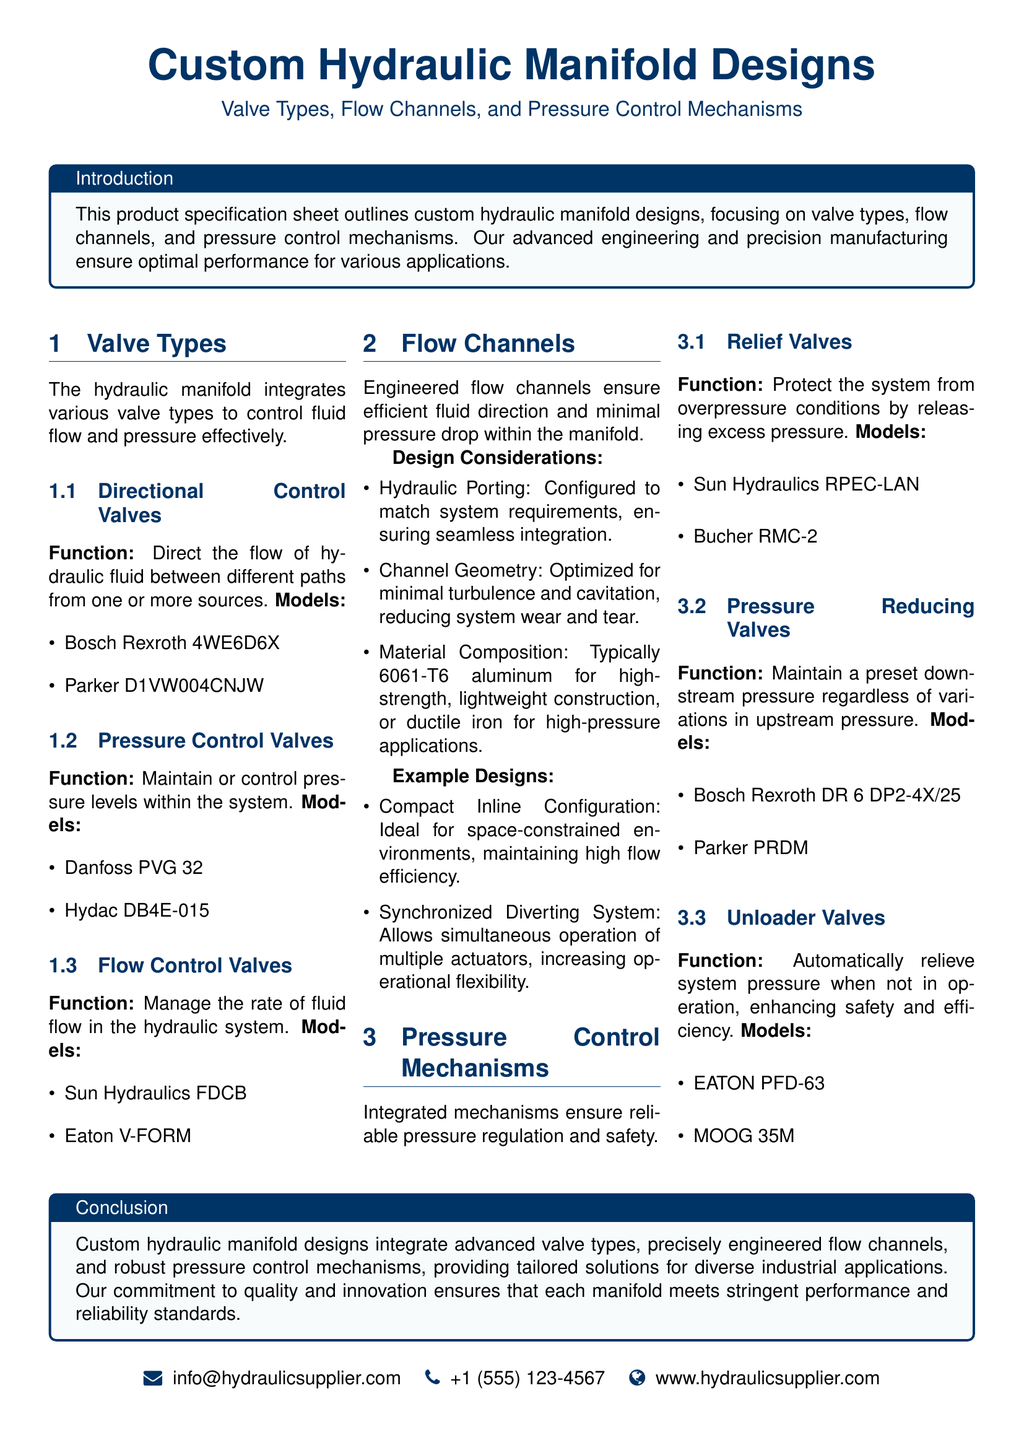What is the title of the document? The title encapsulates the main subject of the document regarding hydraulic systems.
Answer: Custom Hydraulic Manifold Designs What are the two types of valves mentioned for pressure control? This is derived from the section discussing different valve types, specifically pressure control valves.
Answer: Pressure Control Valves, Flow Control Valves Which model is listed under Directional Control Valves? This question seeks specific information from the document's valve lists.
Answer: Bosch Rexroth 4WE6D6X What is the material composition typically used for flow channels? The answer is found in the design considerations section related to materials.
Answer: 6061-T6 aluminum What is the function of Relief Valves? This question pertains to the specific function described for pressure control mechanisms.
Answer: Protect the system from overpressure conditions How many example designs are provided under Flow Channels? This checks comprehension of the content structure detailing multiple example designs.
Answer: Two What is the function of Pressure Reducing Valves? This question requires recalling specific information about pressure control valve functions.
Answer: Maintain a preset downstream pressure What type of document is this? The descriptor of the document is crucial for contextual understanding.
Answer: Product specification sheet 